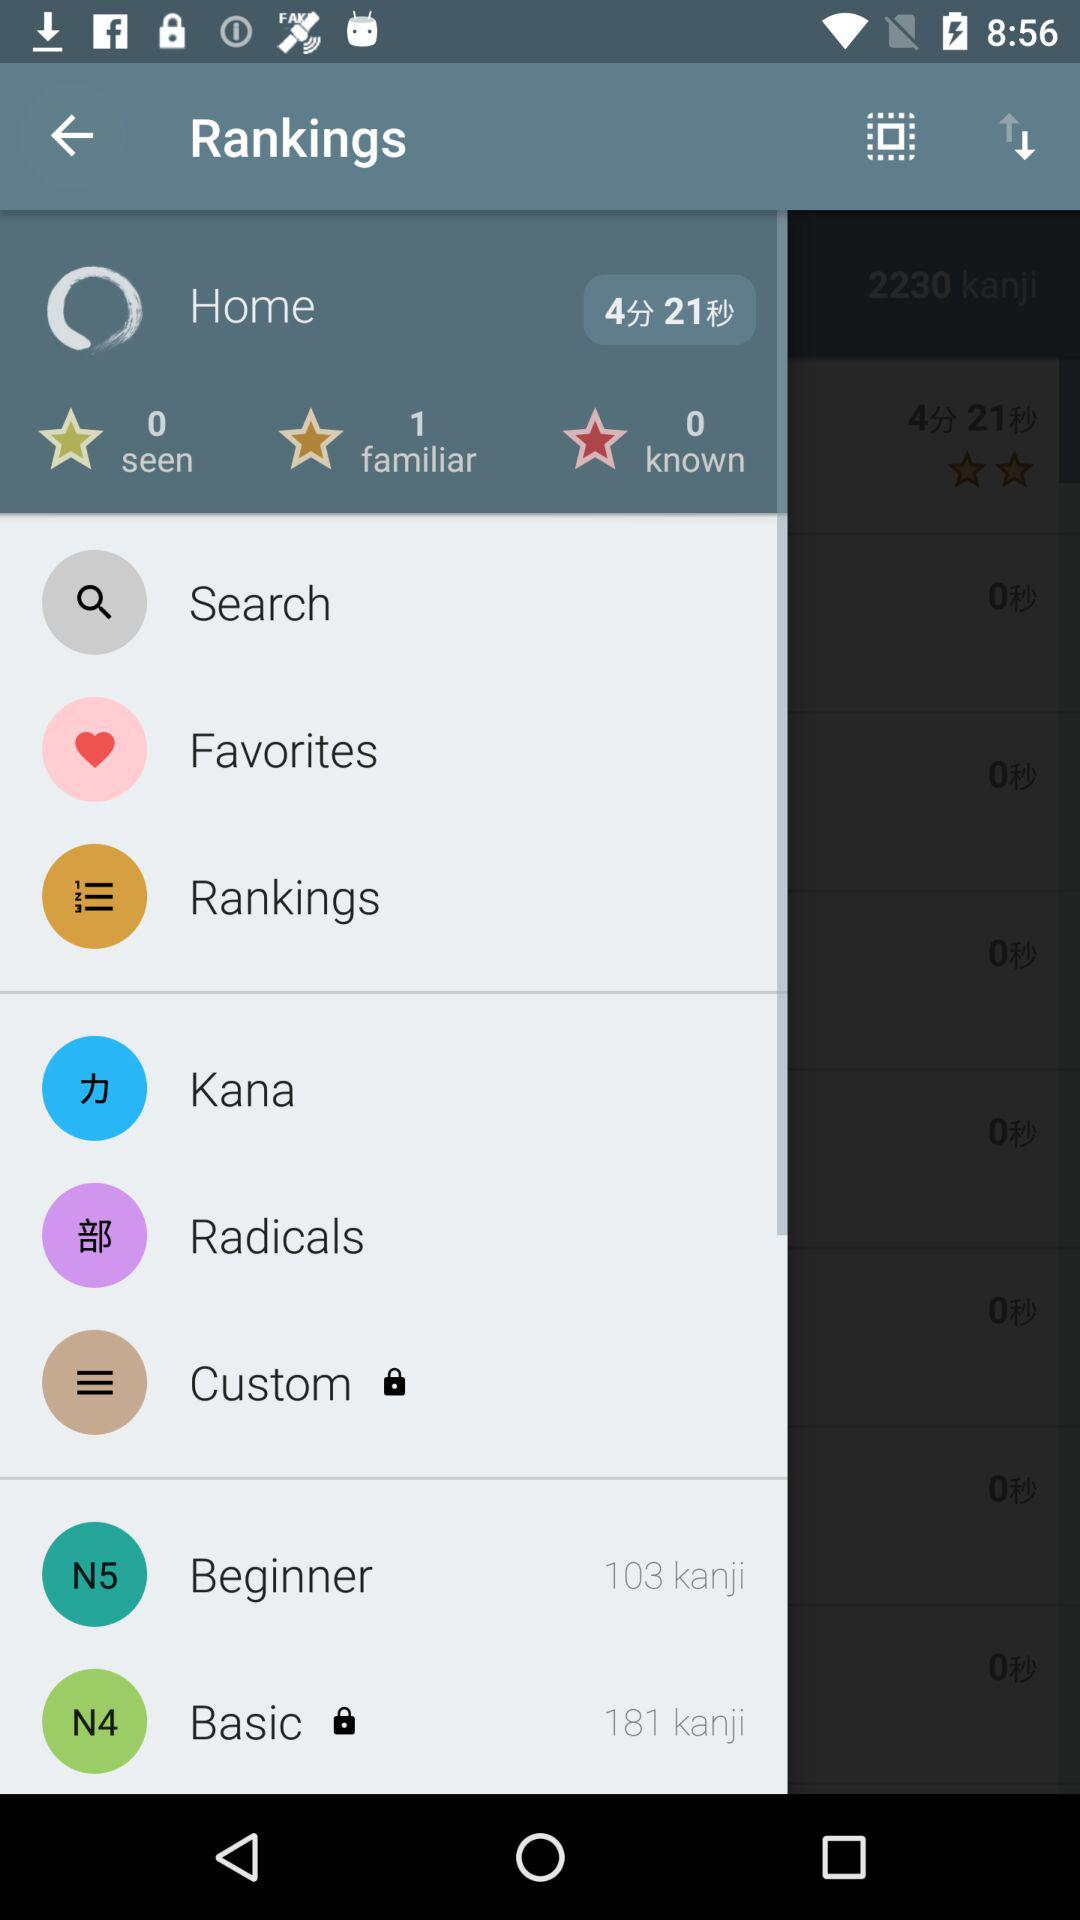What is the number of "seen"? The number is 0. 